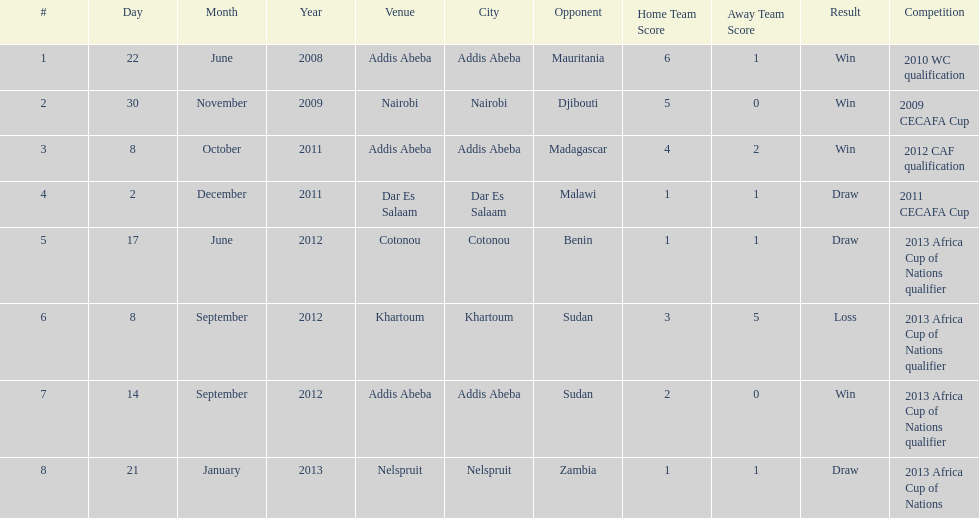What date gives was their only loss? 8 September 2012. 